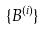<formula> <loc_0><loc_0><loc_500><loc_500>\{ B ^ { ( i ) } \}</formula> 